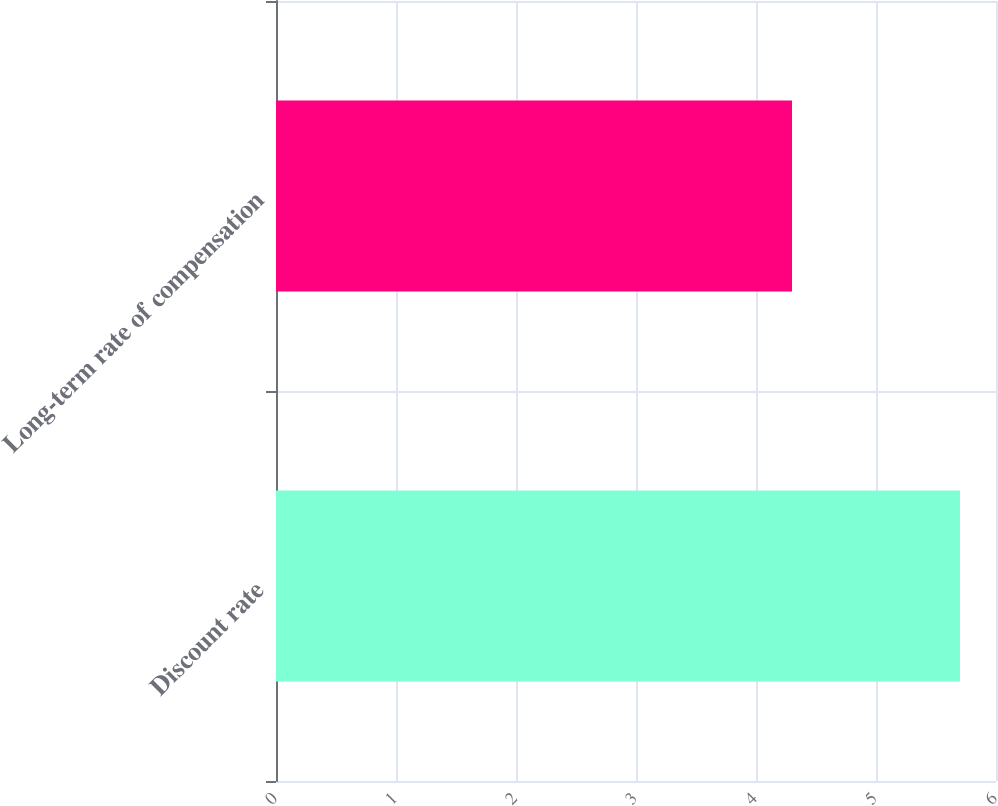Convert chart. <chart><loc_0><loc_0><loc_500><loc_500><bar_chart><fcel>Discount rate<fcel>Long-term rate of compensation<nl><fcel>5.7<fcel>4.3<nl></chart> 